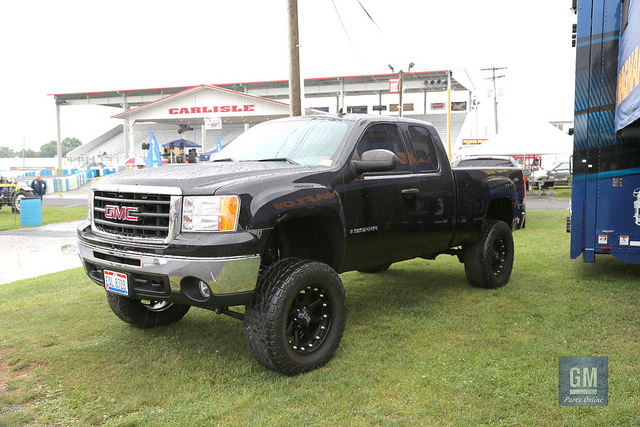Extract all visible text content from this image. CARLISLE GMC Online GM 